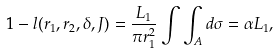Convert formula to latex. <formula><loc_0><loc_0><loc_500><loc_500>1 - l ( r _ { 1 } , r _ { 2 } , \delta , J ) = \frac { L _ { 1 } } { \pi r _ { 1 } ^ { 2 } } \int \int _ { A } d \sigma = \alpha L _ { 1 } ,</formula> 